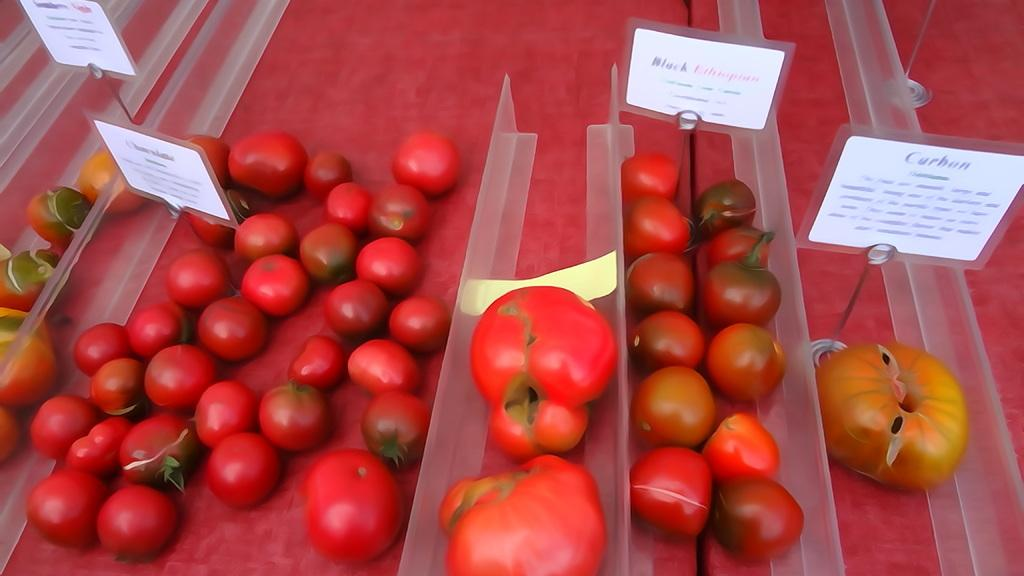What type of food can be seen in the image? There are colorful vegetables in the image. Where are the vegetables located? The vegetables are likely on tables in the image. What separates the vegetables on the tables? Plastic dividers are visible in the image. How can you identify the different vegetables? Name plates are present in the image to identify the vegetables. What type of straw is used to hold the vegetables in the image? There is no straw present in the image; the vegetables are likely on tables with plastic dividers and name plates. 